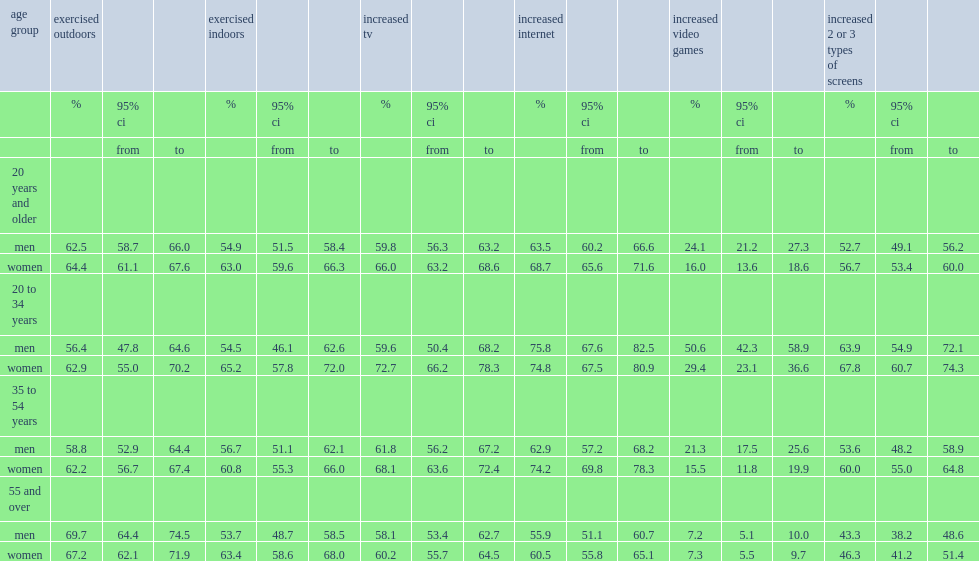Would you mind parsing the complete table? {'header': ['age group', 'exercised outdoors', '', '', 'exercised indoors', '', '', 'increased tv', '', '', 'increased internet', '', '', 'increased video games', '', '', 'increased 2 or 3 types of screens', '', ''], 'rows': [['', '%', '95% ci', '', '%', '95% ci', '', '%', '95% ci', '', '%', '95% ci', '', '%', '95% ci', '', '%', '95% ci', ''], ['', '', 'from', 'to', '', 'from', 'to', '', 'from', 'to', '', 'from', 'to', '', 'from', 'to', '', 'from', 'to'], ['20 years and older', '', '', '', '', '', '', '', '', '', '', '', '', '', '', '', '', '', ''], ['men', '62.5', '58.7', '66.0', '54.9', '51.5', '58.4', '59.8', '56.3', '63.2', '63.5', '60.2', '66.6', '24.1', '21.2', '27.3', '52.7', '49.1', '56.2'], ['women', '64.4', '61.1', '67.6', '63.0', '59.6', '66.3', '66.0', '63.2', '68.6', '68.7', '65.6', '71.6', '16.0', '13.6', '18.6', '56.7', '53.4', '60.0'], ['20 to 34 years', '', '', '', '', '', '', '', '', '', '', '', '', '', '', '', '', '', ''], ['men', '56.4', '47.8', '64.6', '54.5', '46.1', '62.6', '59.6', '50.4', '68.2', '75.8', '67.6', '82.5', '50.6', '42.3', '58.9', '63.9', '54.9', '72.1'], ['women', '62.9', '55.0', '70.2', '65.2', '57.8', '72.0', '72.7', '66.2', '78.3', '74.8', '67.5', '80.9', '29.4', '23.1', '36.6', '67.8', '60.7', '74.3'], ['35 to 54 years', '', '', '', '', '', '', '', '', '', '', '', '', '', '', '', '', '', ''], ['men', '58.8', '52.9', '64.4', '56.7', '51.1', '62.1', '61.8', '56.2', '67.2', '62.9', '57.2', '68.2', '21.3', '17.5', '25.6', '53.6', '48.2', '58.9'], ['women', '62.2', '56.7', '67.4', '60.8', '55.3', '66.0', '68.1', '63.6', '72.4', '74.2', '69.8', '78.3', '15.5', '11.8', '19.9', '60.0', '55.0', '64.8'], ['55 and over', '', '', '', '', '', '', '', '', '', '', '', '', '', '', '', '', '', ''], ['men', '69.7', '64.4', '74.5', '53.7', '48.7', '58.5', '58.1', '53.4', '62.7', '55.9', '51.1', '60.7', '7.2', '5.1', '10.0', '43.3', '38.2', '48.6'], ['women', '67.2', '62.1', '71.9', '63.4', '58.6', '68.0', '60.2', '55.7', '64.5', '60.5', '55.8', '65.1', '7.3', '5.5', '9.7', '46.3', '41.2', '51.4']]} What the percent of men and women reported exercising outdoors? 64.4. Which sex reported exercising indoors, women or men? Women. What was the percentage of men aged 55+ years reported exercising outdoors? 69.7. What was the percentage of men aged 20 to 34 years reported exercising outdoors? 56.4. What was the percentage of men aged 35 to 54 years reported exercising outdoors? 58.8. 